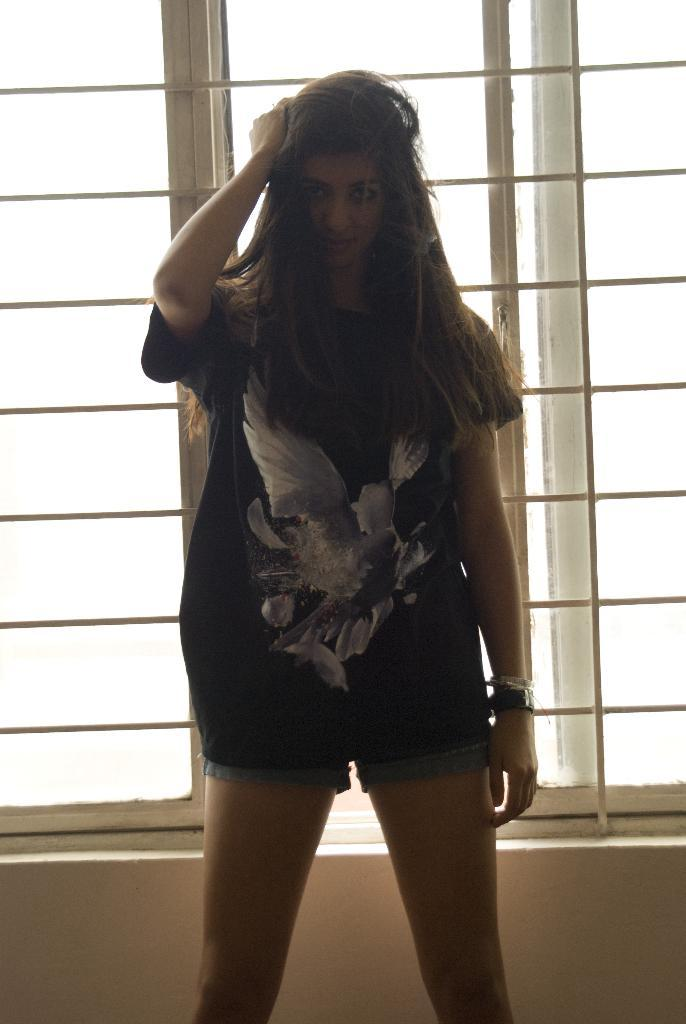What is the main subject in the image? There is a woman standing in the image. Can you describe the background of the image? There is a window visible in the background of the image. What type of knowledge can be seen in the woman's hand in the image? There is no knowledge or any object resembling knowledge present in the woman's hand in the image. 